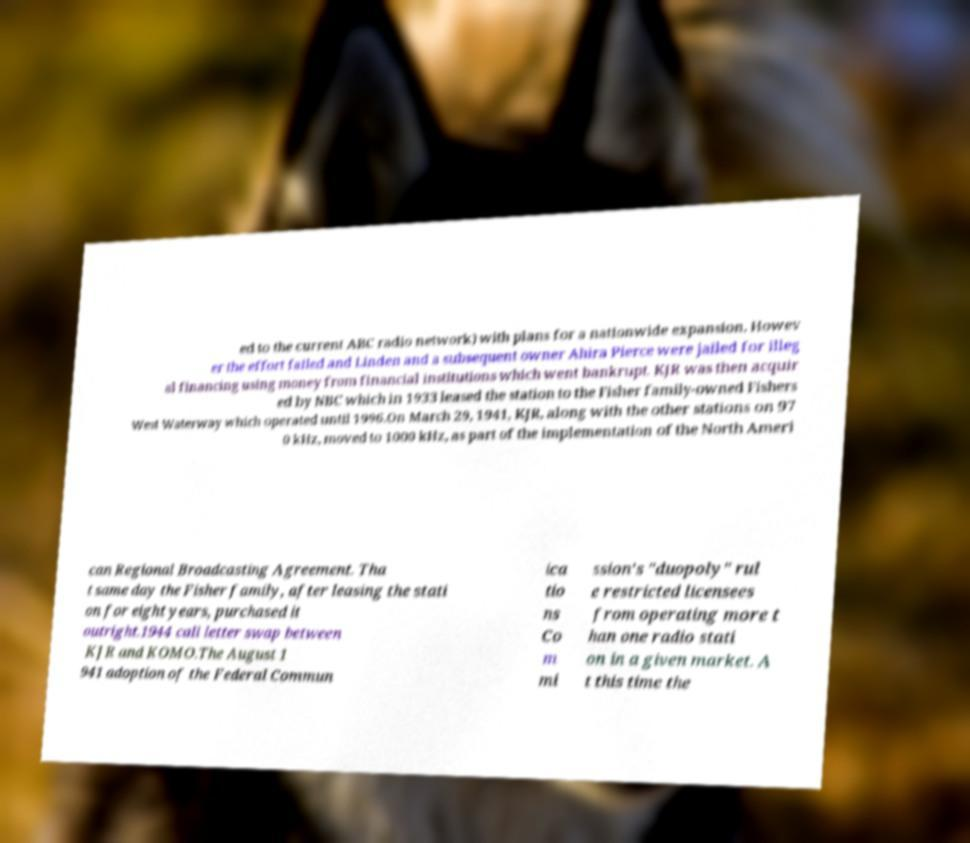There's text embedded in this image that I need extracted. Can you transcribe it verbatim? ed to the current ABC radio network) with plans for a nationwide expansion. Howev er the effort failed and Linden and a subsequent owner Ahira Pierce were jailed for illeg al financing using money from financial institutions which went bankrupt. KJR was then acquir ed by NBC which in 1933 leased the station to the Fisher family-owned Fishers West Waterway which operated until 1996.On March 29, 1941, KJR, along with the other stations on 97 0 kHz, moved to 1000 kHz, as part of the implementation of the North Ameri can Regional Broadcasting Agreement. Tha t same day the Fisher family, after leasing the stati on for eight years, purchased it outright.1944 call letter swap between KJR and KOMO.The August 1 941 adoption of the Federal Commun ica tio ns Co m mi ssion's "duopoly" rul e restricted licensees from operating more t han one radio stati on in a given market. A t this time the 